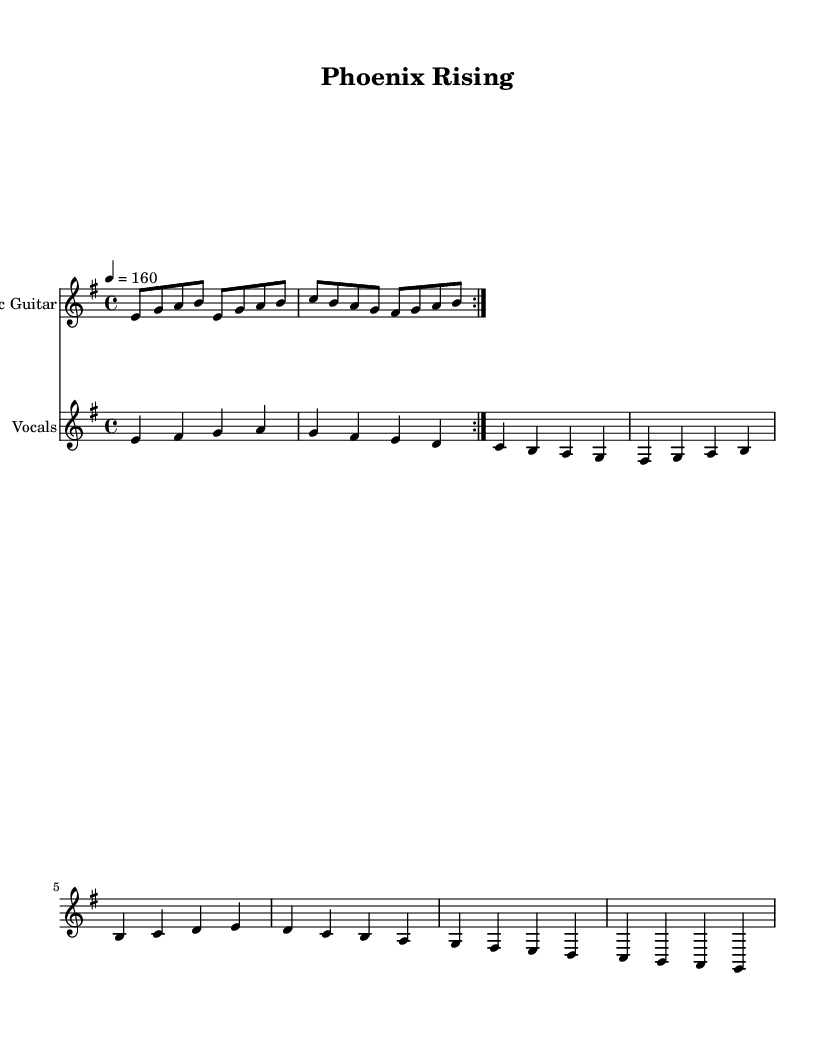What is the key signature of this music? The key signature is E minor, which has one sharp (F#) as indicated in the beginning of the score.
Answer: E minor What is the time signature of the piece? The time signature is 4/4, as denoted at the start of the score. This means there are four beats per measure with each beat being a quarter note.
Answer: 4/4 What is the tempo marking for this piece? The tempo marking is 160 beats per minute, stated as "4 = 160," meaning the quarter note is played at 160 beats per minute.
Answer: 160 How many measures are included in the verse section? The verse section consists of four measures, showing distinct melodic movement within these bars.
Answer: 4 What lyrical theme is presented in the chorus? The chorus emphasizes resilience and unity, suggesting strength in facing challenges together after conflict, with lines about rising from ashes and standing united.
Answer: resilience and unity What type of articulation does the electric guitar section use? The electric guitar part features a repeating rhythmic pattern, which is typical in metal music to create a driving, aggressive sound.
Answer: driving rhythmic pattern How is the vocal melody structured in relation to the guitar? The vocal melody moves in a complementary fashion to the electric guitar, alternating between sustained notes and rhythmic phrases, typical of a heavy metal anthem.
Answer: complementary structure 